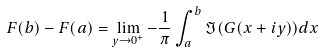<formula> <loc_0><loc_0><loc_500><loc_500>F ( b ) - F ( a ) = \lim _ { y \rightarrow 0 ^ { + } } - \frac { 1 } { \pi } \int _ { a } ^ { b } \Im ( G ( x + i y ) ) d x</formula> 